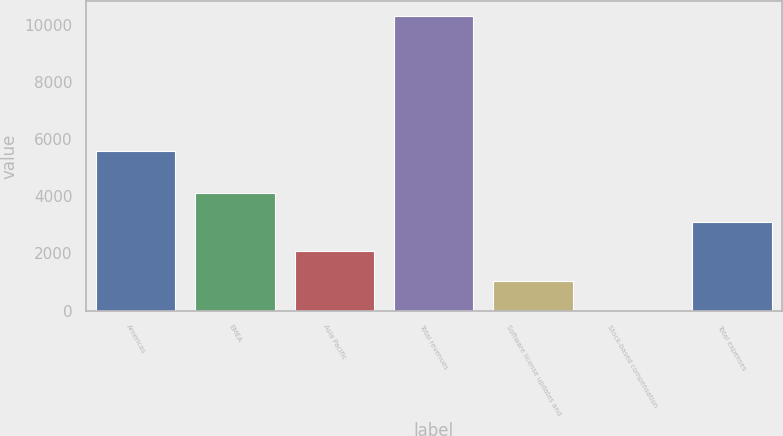Convert chart. <chart><loc_0><loc_0><loc_500><loc_500><bar_chart><fcel>Americas<fcel>EMEA<fcel>Asia Pacific<fcel>Total revenues<fcel>Software license updates and<fcel>Stock-based compensation<fcel>Total expenses<nl><fcel>5587<fcel>4137.2<fcel>2073.6<fcel>10328<fcel>1041.8<fcel>10<fcel>3105.4<nl></chart> 